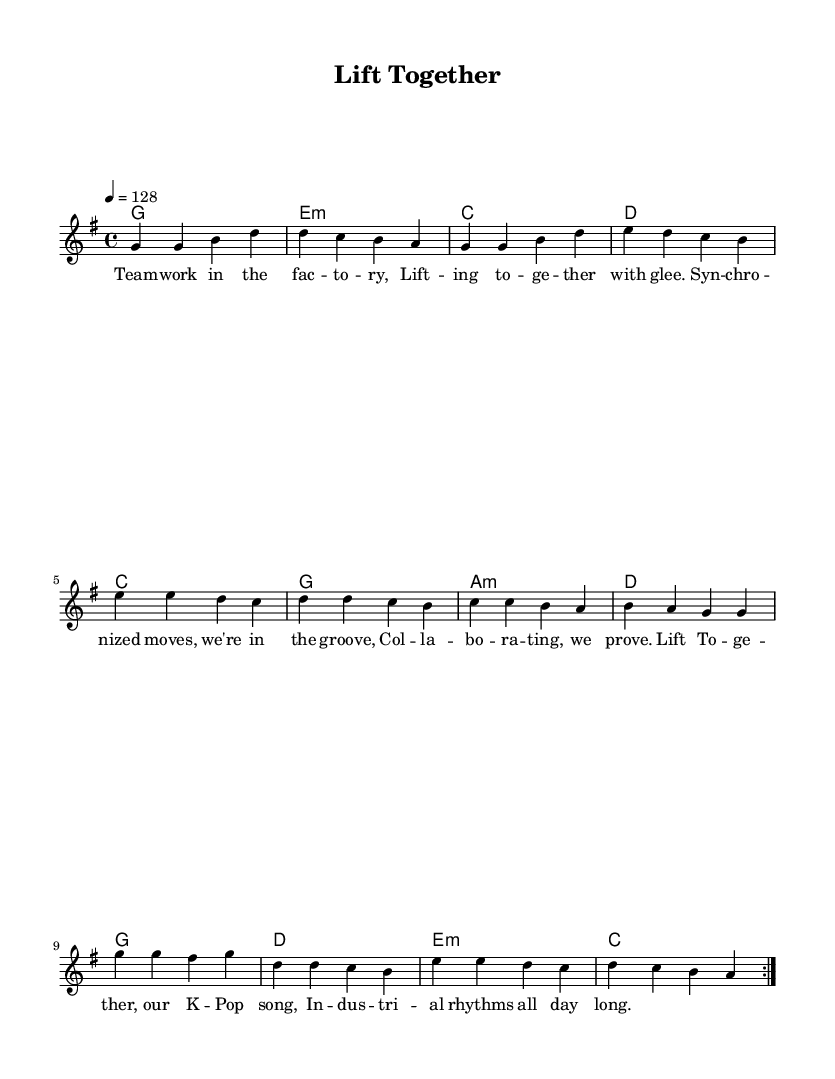what is the key signature of this music? The key signature is G major, which has one sharp (F#). This is indicated by the presence of F# in the melody notes and harmonies.
Answer: G major what is the time signature of this music? The time signature is 4/4, which is shown at the beginning of the score as a standard measure for most pop music including K-Pop. This means there are four beats in each measure.
Answer: 4/4 what is the tempo marking for this piece? The tempo is indicated as 128 beats per minute, which is stated clearly within the tempo marking at the beginning. This suggests a lively pace suitable for dance music.
Answer: 128 how many measures are repeated in the melody section? The melody section includes a repeat, indicated by the "volta" marking. Observing the structure, it repeats for two iterations across the given section.
Answer: 2 what theme do the lyrics of this music represent? The lyrics reflect themes of teamwork and collaboration in an industrial setting. Phrases like "lifting together" and "synchronized moves" emphasize group effort and unity.
Answer: Teamwork which musical form is primarily used in this K-Pop piece? The piece follows a verse structure typical of K-Pop songs that incorporates repetition of melodies and lyrics which attracts listeners and encourages participation.
Answer: Verse 